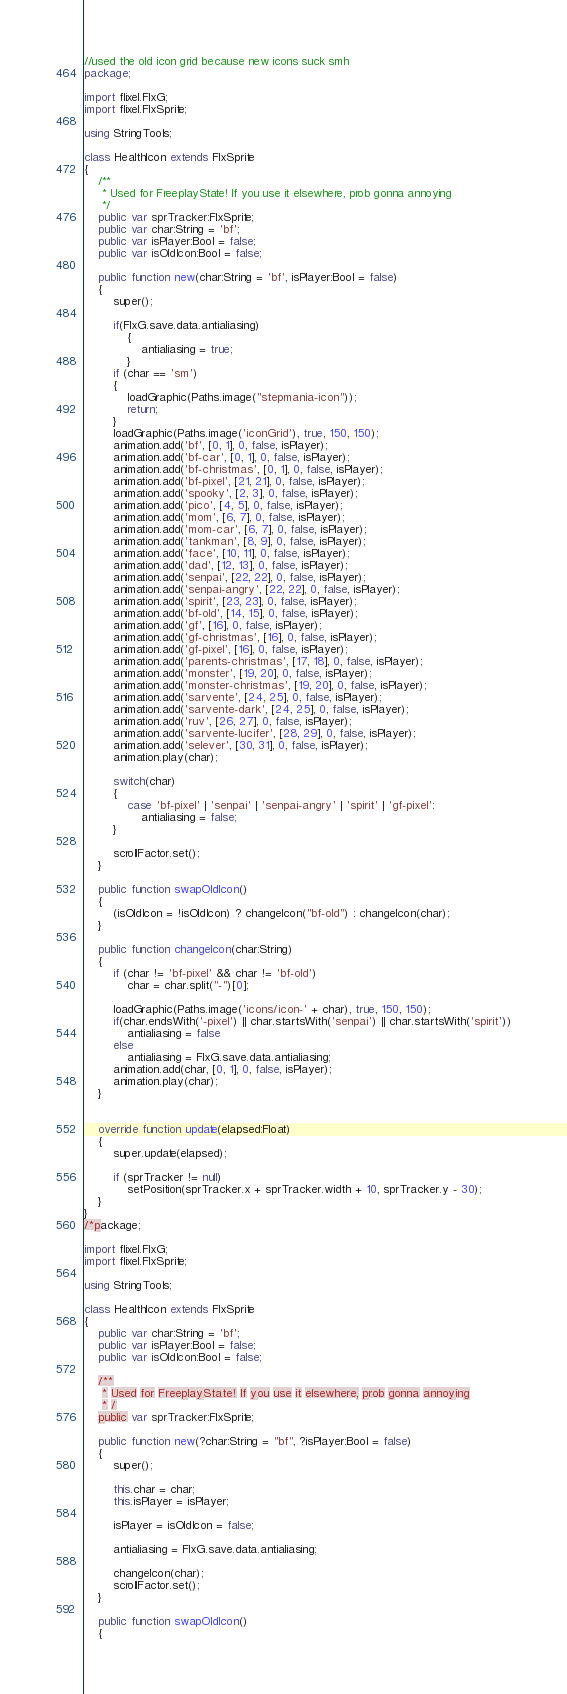Convert code to text. <code><loc_0><loc_0><loc_500><loc_500><_Haxe_>//used the old icon grid because new icons suck smh
package;

import flixel.FlxG;
import flixel.FlxSprite;

using StringTools;

class HealthIcon extends FlxSprite
{
	/**
	 * Used for FreeplayState! If you use it elsewhere, prob gonna annoying
	 */
	public var sprTracker:FlxSprite;
	public var char:String = 'bf';
	public var isPlayer:Bool = false;
	public var isOldIcon:Bool = false;

	public function new(char:String = 'bf', isPlayer:Bool = false)
	{
		super();

		if(FlxG.save.data.antialiasing)
			{
				antialiasing = true;
			}
		if (char == 'sm')
		{
			loadGraphic(Paths.image("stepmania-icon"));
			return;
		}
		loadGraphic(Paths.image('iconGrid'), true, 150, 150);
		animation.add('bf', [0, 1], 0, false, isPlayer);
		animation.add('bf-car', [0, 1], 0, false, isPlayer);
		animation.add('bf-christmas', [0, 1], 0, false, isPlayer);
		animation.add('bf-pixel', [21, 21], 0, false, isPlayer);
		animation.add('spooky', [2, 3], 0, false, isPlayer);
		animation.add('pico', [4, 5], 0, false, isPlayer);
		animation.add('mom', [6, 7], 0, false, isPlayer);
		animation.add('mom-car', [6, 7], 0, false, isPlayer);
		animation.add('tankman', [8, 9], 0, false, isPlayer);
		animation.add('face', [10, 11], 0, false, isPlayer);
		animation.add('dad', [12, 13], 0, false, isPlayer);
		animation.add('senpai', [22, 22], 0, false, isPlayer);
		animation.add('senpai-angry', [22, 22], 0, false, isPlayer);
		animation.add('spirit', [23, 23], 0, false, isPlayer);
		animation.add('bf-old', [14, 15], 0, false, isPlayer);
		animation.add('gf', [16], 0, false, isPlayer);
		animation.add('gf-christmas', [16], 0, false, isPlayer);
		animation.add('gf-pixel', [16], 0, false, isPlayer);
		animation.add('parents-christmas', [17, 18], 0, false, isPlayer);
		animation.add('monster', [19, 20], 0, false, isPlayer);
		animation.add('monster-christmas', [19, 20], 0, false, isPlayer);
		animation.add('sarvente', [24, 25], 0, false, isPlayer);
		animation.add('sarvente-dark', [24, 25], 0, false, isPlayer);
		animation.add('ruv', [26, 27], 0, false, isPlayer);
		animation.add('sarvente-lucifer', [28, 29], 0, false, isPlayer);
		animation.add('selever', [30, 31], 0, false, isPlayer);
		animation.play(char);

		switch(char)
		{
			case 'bf-pixel' | 'senpai' | 'senpai-angry' | 'spirit' | 'gf-pixel':
				antialiasing = false;
		}

		scrollFactor.set();
	}

	public function swapOldIcon()
	{
		(isOldIcon = !isOldIcon) ? changeIcon("bf-old") : changeIcon(char);
	}

	public function changeIcon(char:String)
	{
		if (char != 'bf-pixel' && char != 'bf-old')
			char = char.split("-")[0];

		loadGraphic(Paths.image('icons/icon-' + char), true, 150, 150);
		if(char.endsWith('-pixel') || char.startsWith('senpai') || char.startsWith('spirit'))
			antialiasing = false
		else
			antialiasing = FlxG.save.data.antialiasing;
		animation.add(char, [0, 1], 0, false, isPlayer);
		animation.play(char);
	}
	

	override function update(elapsed:Float)
	{
		super.update(elapsed);

		if (sprTracker != null)
			setPosition(sprTracker.x + sprTracker.width + 10, sprTracker.y - 30);
	}
}
/*package;

import flixel.FlxG;
import flixel.FlxSprite;

using StringTools;

class HealthIcon extends FlxSprite
{
	public var char:String = 'bf';
	public var isPlayer:Bool = false;
	public var isOldIcon:Bool = false;

	/**
	 * Used for FreeplayState! If you use it elsewhere, prob gonna annoying
	 * /
	public var sprTracker:FlxSprite;

	public function new(?char:String = "bf", ?isPlayer:Bool = false)
	{
		super();

		this.char = char;
		this.isPlayer = isPlayer;

		isPlayer = isOldIcon = false;

		antialiasing = FlxG.save.data.antialiasing;

		changeIcon(char);
		scrollFactor.set();
	}

	public function swapOldIcon()
	{</code> 